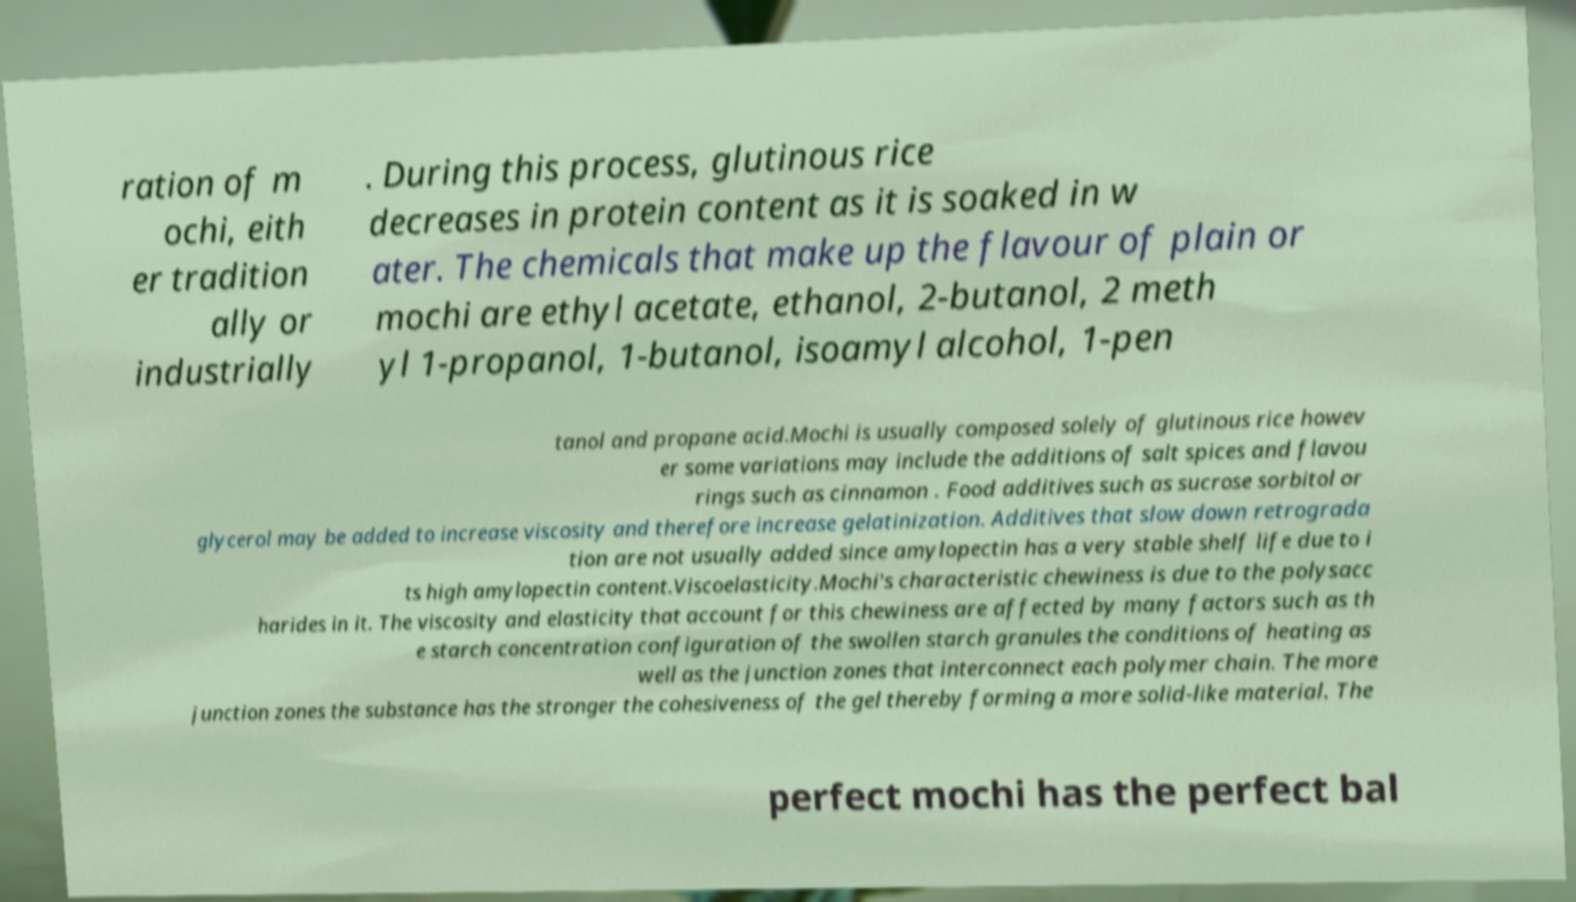Could you extract and type out the text from this image? ration of m ochi, eith er tradition ally or industrially . During this process, glutinous rice decreases in protein content as it is soaked in w ater. The chemicals that make up the flavour of plain or mochi are ethyl acetate, ethanol, 2-butanol, 2 meth yl 1-propanol, 1-butanol, isoamyl alcohol, 1-pen tanol and propane acid.Mochi is usually composed solely of glutinous rice howev er some variations may include the additions of salt spices and flavou rings such as cinnamon . Food additives such as sucrose sorbitol or glycerol may be added to increase viscosity and therefore increase gelatinization. Additives that slow down retrograda tion are not usually added since amylopectin has a very stable shelf life due to i ts high amylopectin content.Viscoelasticity.Mochi's characteristic chewiness is due to the polysacc harides in it. The viscosity and elasticity that account for this chewiness are affected by many factors such as th e starch concentration configuration of the swollen starch granules the conditions of heating as well as the junction zones that interconnect each polymer chain. The more junction zones the substance has the stronger the cohesiveness of the gel thereby forming a more solid-like material. The perfect mochi has the perfect bal 